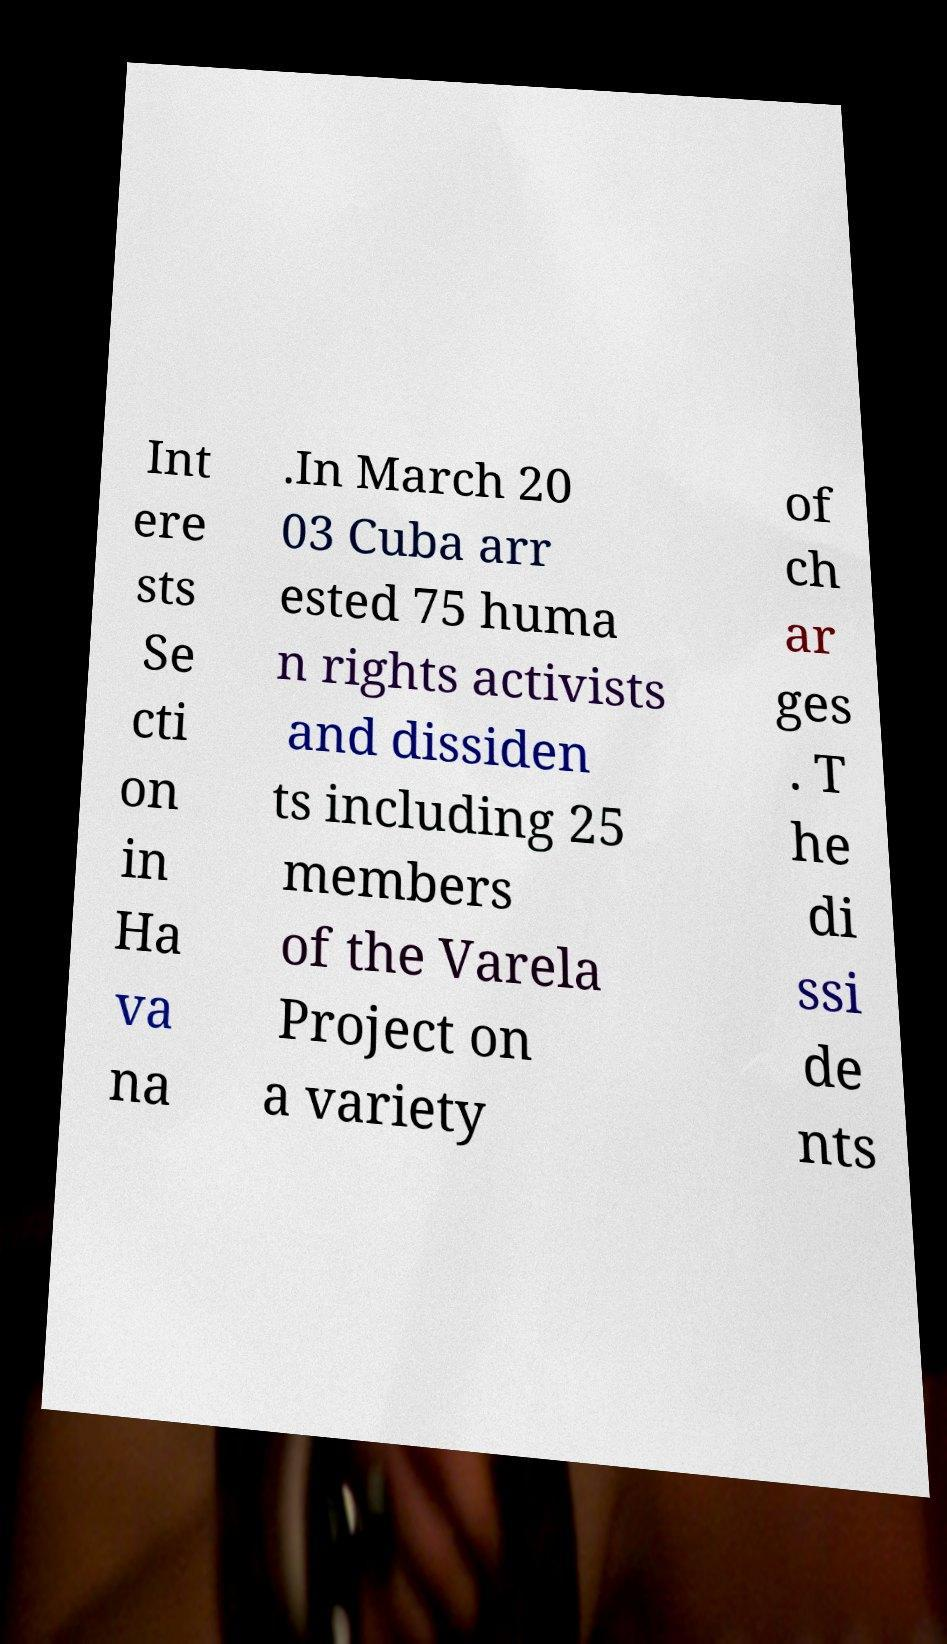There's text embedded in this image that I need extracted. Can you transcribe it verbatim? Int ere sts Se cti on in Ha va na .In March 20 03 Cuba arr ested 75 huma n rights activists and dissiden ts including 25 members of the Varela Project on a variety of ch ar ges . T he di ssi de nts 